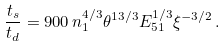Convert formula to latex. <formula><loc_0><loc_0><loc_500><loc_500>\frac { t _ { s } } { t _ { d } } = 9 0 0 \, n _ { 1 } ^ { 4 / 3 } \theta ^ { 1 3 / 3 } E _ { 5 1 } ^ { 1 / 3 } \xi ^ { - 3 / 2 } \, .</formula> 